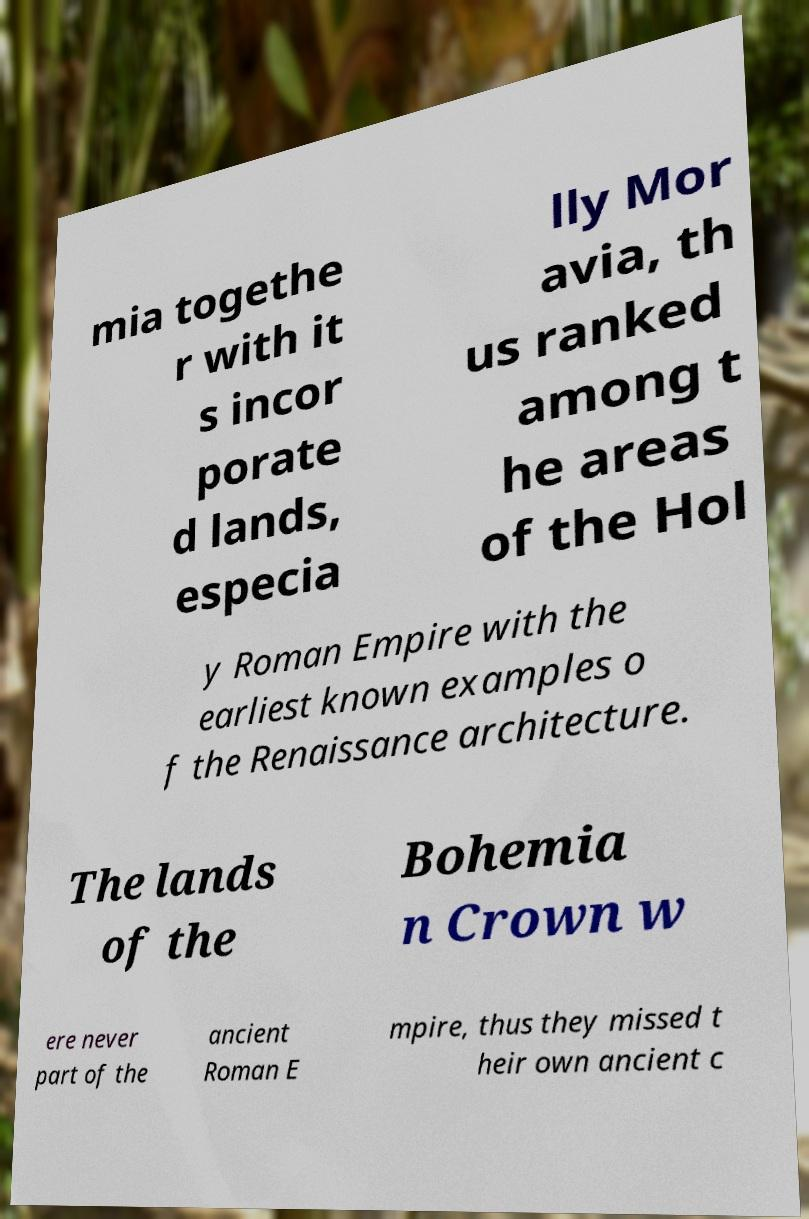Please read and relay the text visible in this image. What does it say? mia togethe r with it s incor porate d lands, especia lly Mor avia, th us ranked among t he areas of the Hol y Roman Empire with the earliest known examples o f the Renaissance architecture. The lands of the Bohemia n Crown w ere never part of the ancient Roman E mpire, thus they missed t heir own ancient c 